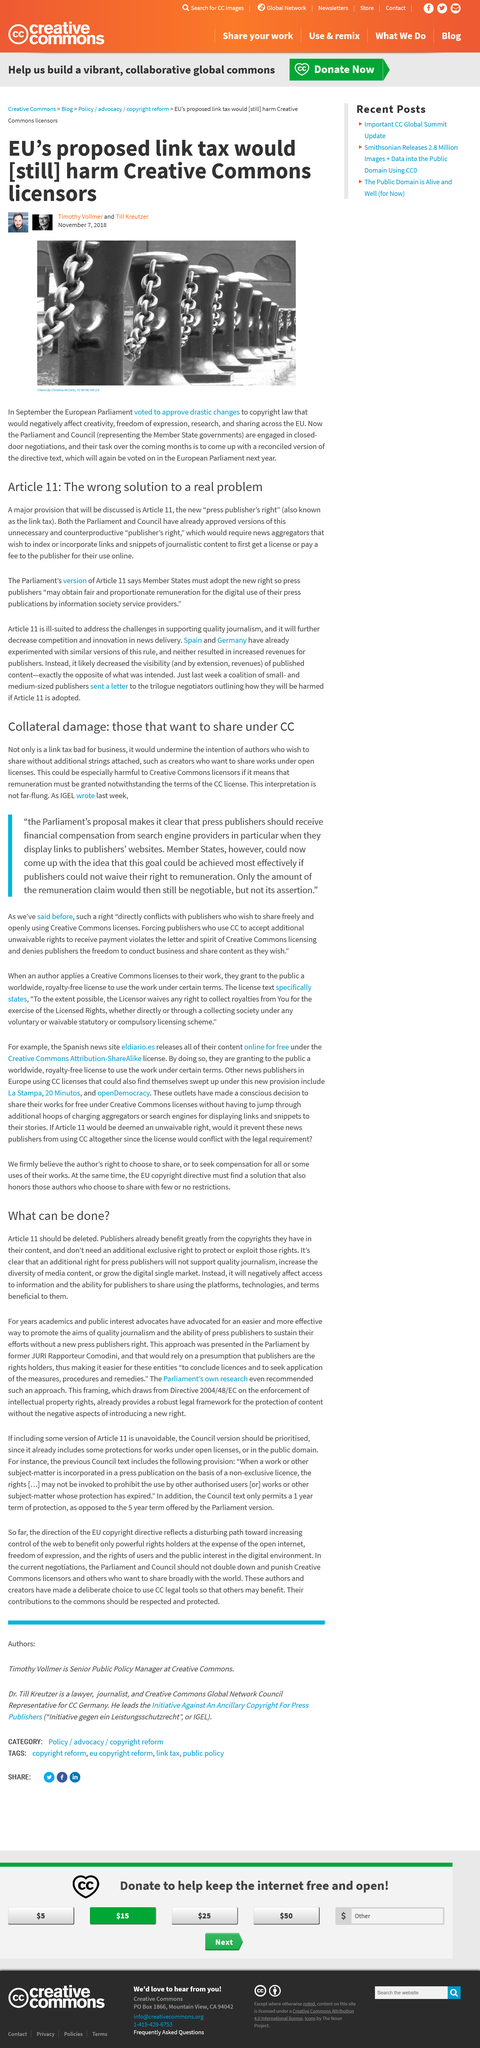Give some essential details in this illustration. The authors of this text are Timothy Vollmer and Till Kreutzer. The article pertains to the topic of taxing. The article was published on November 7, 2018. 